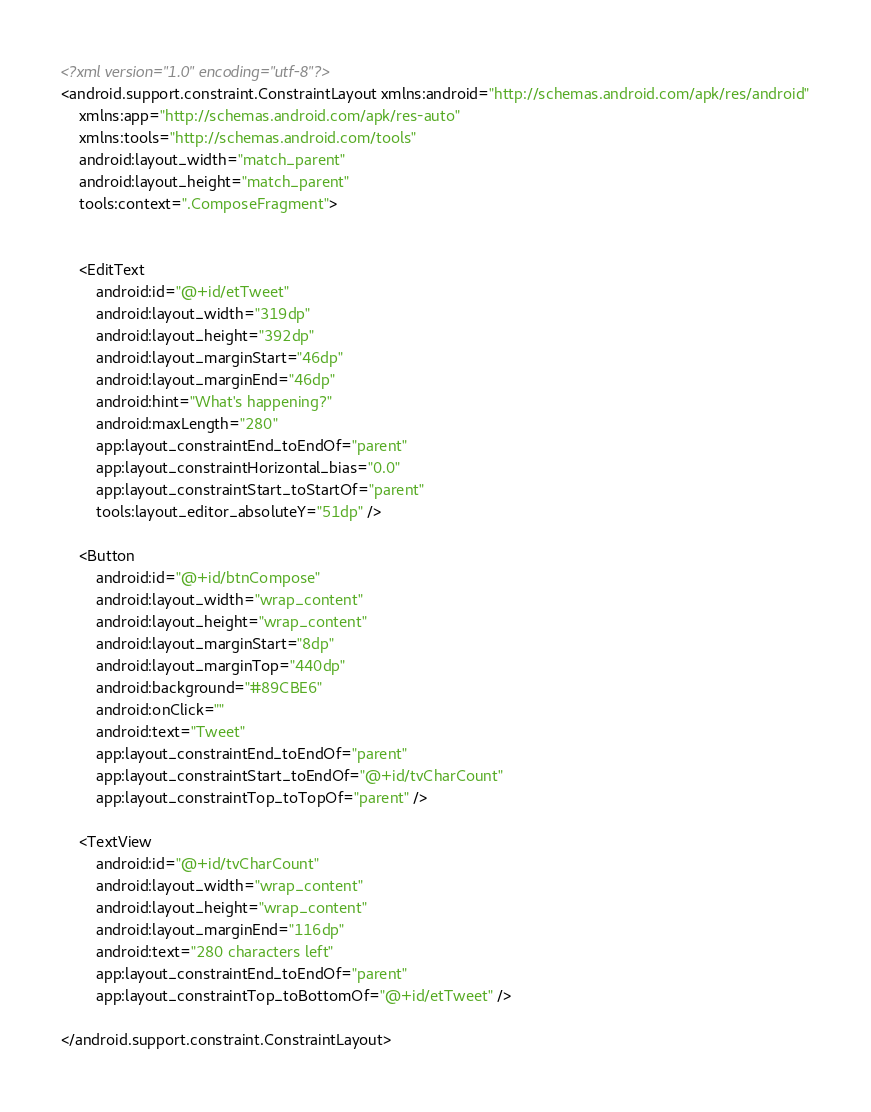Convert code to text. <code><loc_0><loc_0><loc_500><loc_500><_XML_><?xml version="1.0" encoding="utf-8"?>
<android.support.constraint.ConstraintLayout xmlns:android="http://schemas.android.com/apk/res/android"
    xmlns:app="http://schemas.android.com/apk/res-auto"
    xmlns:tools="http://schemas.android.com/tools"
    android:layout_width="match_parent"
    android:layout_height="match_parent"
    tools:context=".ComposeFragment">


    <EditText
        android:id="@+id/etTweet"
        android:layout_width="319dp"
        android:layout_height="392dp"
        android:layout_marginStart="46dp"
        android:layout_marginEnd="46dp"
        android:hint="What's happening?"
        android:maxLength="280"
        app:layout_constraintEnd_toEndOf="parent"
        app:layout_constraintHorizontal_bias="0.0"
        app:layout_constraintStart_toStartOf="parent"
        tools:layout_editor_absoluteY="51dp" />

    <Button
        android:id="@+id/btnCompose"
        android:layout_width="wrap_content"
        android:layout_height="wrap_content"
        android:layout_marginStart="8dp"
        android:layout_marginTop="440dp"
        android:background="#89CBE6"
        android:onClick=""
        android:text="Tweet"
        app:layout_constraintEnd_toEndOf="parent"
        app:layout_constraintStart_toEndOf="@+id/tvCharCount"
        app:layout_constraintTop_toTopOf="parent" />

    <TextView
        android:id="@+id/tvCharCount"
        android:layout_width="wrap_content"
        android:layout_height="wrap_content"
        android:layout_marginEnd="116dp"
        android:text="280 characters left"
        app:layout_constraintEnd_toEndOf="parent"
        app:layout_constraintTop_toBottomOf="@+id/etTweet" />

</android.support.constraint.ConstraintLayout></code> 